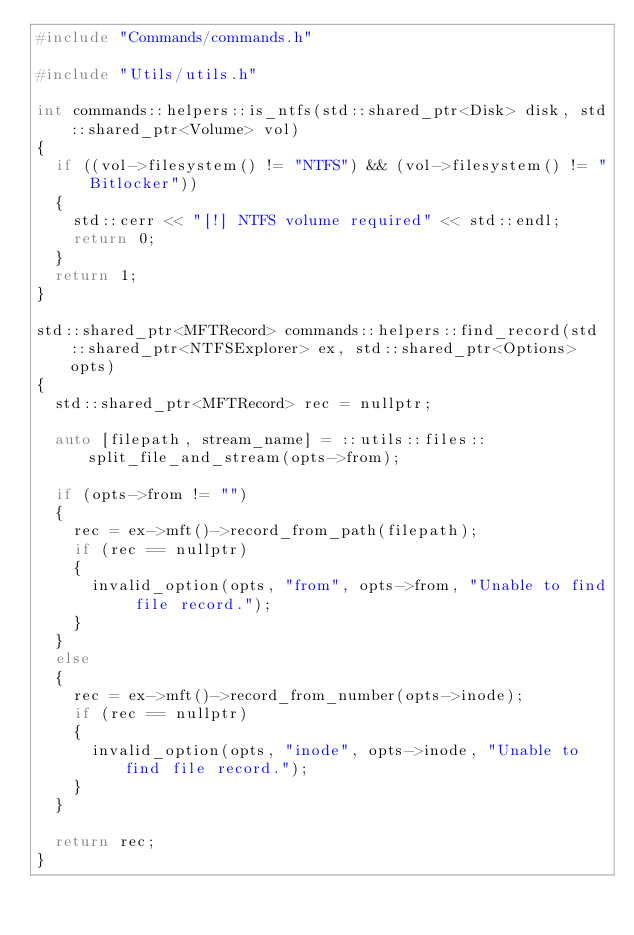<code> <loc_0><loc_0><loc_500><loc_500><_C++_>#include "Commands/commands.h"

#include "Utils/utils.h"

int commands::helpers::is_ntfs(std::shared_ptr<Disk> disk, std::shared_ptr<Volume> vol)
{
	if ((vol->filesystem() != "NTFS") && (vol->filesystem() != "Bitlocker"))
	{
		std::cerr << "[!] NTFS volume required" << std::endl;
		return 0;
	}
	return 1;
}

std::shared_ptr<MFTRecord> commands::helpers::find_record(std::shared_ptr<NTFSExplorer> ex, std::shared_ptr<Options> opts)
{
	std::shared_ptr<MFTRecord> rec = nullptr;

	auto [filepath, stream_name] = ::utils::files::split_file_and_stream(opts->from);

	if (opts->from != "")
	{
		rec = ex->mft()->record_from_path(filepath);
		if (rec == nullptr)
		{
			invalid_option(opts, "from", opts->from, "Unable to find file record.");
		}
	}
	else
	{
		rec = ex->mft()->record_from_number(opts->inode);
		if (rec == nullptr)
		{
			invalid_option(opts, "inode", opts->inode, "Unable to find file record.");
		}
	}

	return rec;
}</code> 